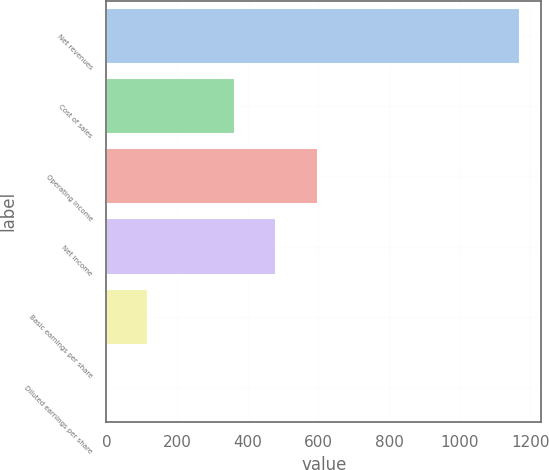Convert chart to OTSL. <chart><loc_0><loc_0><loc_500><loc_500><bar_chart><fcel>Net revenues<fcel>Cost of sales<fcel>Operating income<fcel>Net income<fcel>Basic earnings per share<fcel>Diluted earnings per share<nl><fcel>1172<fcel>364<fcel>598.34<fcel>481.17<fcel>117.5<fcel>0.33<nl></chart> 